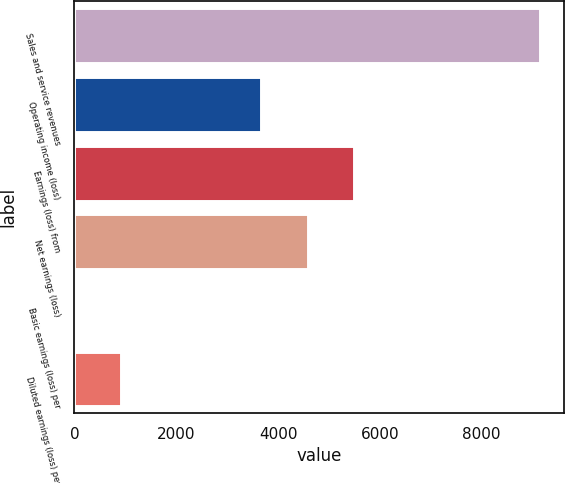Convert chart. <chart><loc_0><loc_0><loc_500><loc_500><bar_chart><fcel>Sales and service revenues<fcel>Operating income (loss)<fcel>Earnings (loss) from<fcel>Net earnings (loss)<fcel>Basic earnings (loss) per<fcel>Diluted earnings (loss) per<nl><fcel>9154<fcel>3666.26<fcel>5495.52<fcel>4580.89<fcel>7.75<fcel>922.38<nl></chart> 